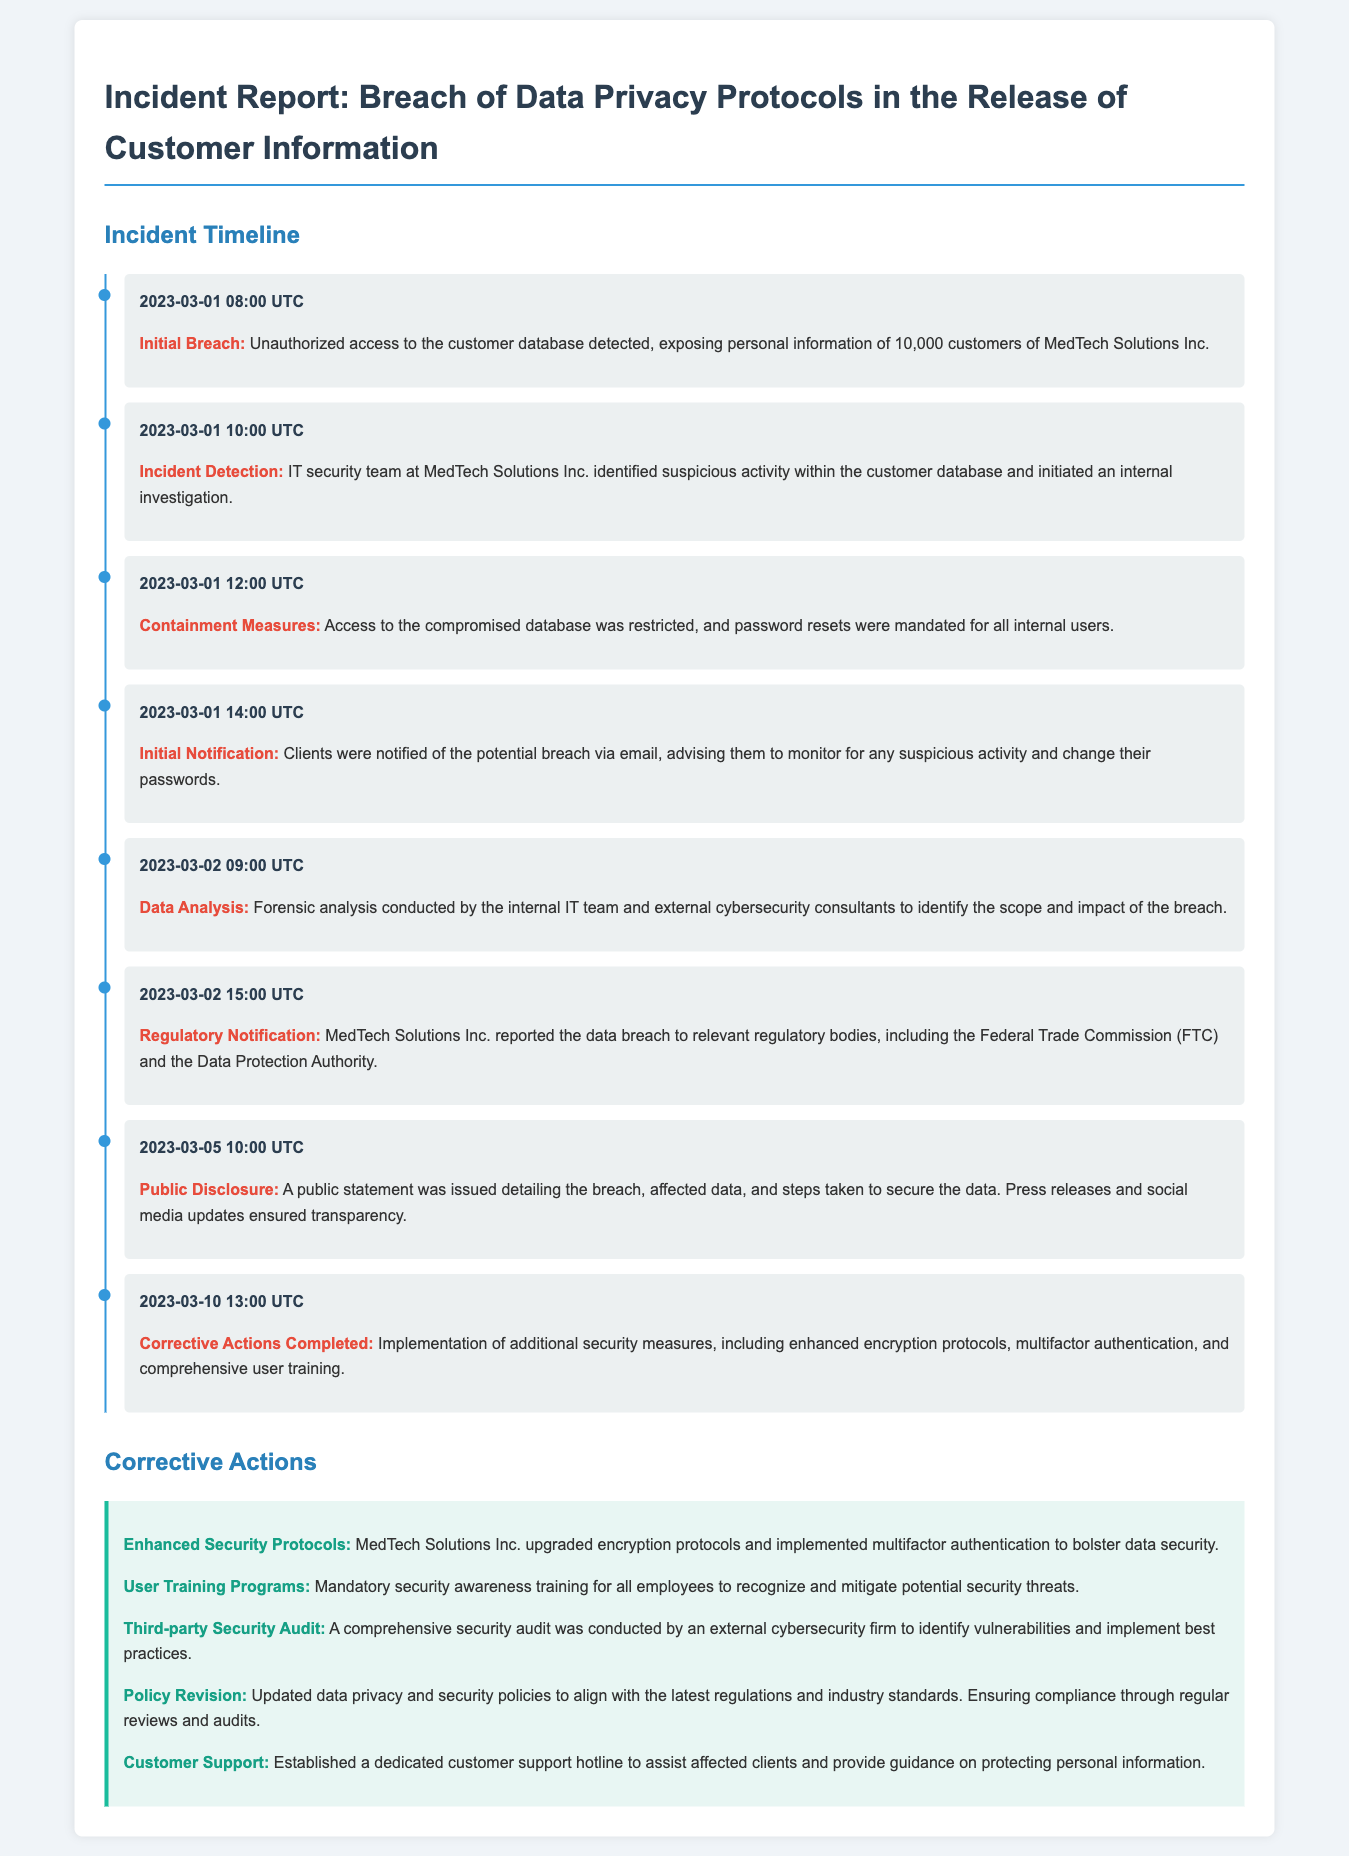What date was the initial breach detected? The initial breach was detected on March 1, 2023.
Answer: March 1, 2023 How many customers were affected by the breach? The document states that the breach exposed personal information of 10,000 customers.
Answer: 10,000 customers What time was the public statement issued? The public statement detailing the breach was issued at 1:00 PM UTC on March 5, 2023.
Answer: 1:00 PM UTC Which regulatory bodies were notified about the breach? MedTech Solutions Inc. reported the breach to the Federal Trade Commission (FTC) and the Data Protection Authority.
Answer: Federal Trade Commission (FTC) and Data Protection Authority What corrective action involved employee education? The document mentions that mandatory security awareness training was implemented for all employees.
Answer: User Training Programs What was the main purpose of the forensic analysis conducted? The forensic analysis aimed to identify the scope and impact of the breach.
Answer: Identify the scope and impact of the breach When were corrective actions completed? Corrective actions were completed on March 10, 2023, at 1:00 PM UTC.
Answer: March 10, 2023 What was a major security measure implemented after the breach? Enhanced encryption protocols were one of the security measures adopted following the breach.
Answer: Enhanced encryption protocols What specific issue did the hotline address? The dedicated customer support hotline was established to assist affected clients with protecting their personal information.
Answer: Protecting personal information 